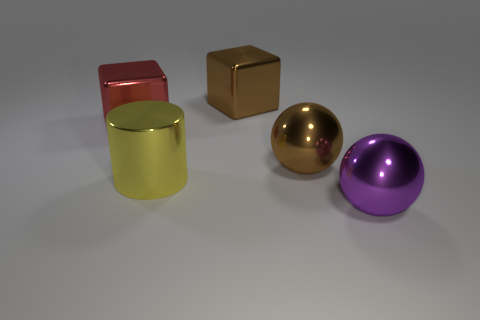What shape is the brown metal thing behind the big brown object that is in front of the metal object left of the big metallic cylinder?
Offer a terse response. Cube. What is the color of the large metal cube in front of the brown block?
Your response must be concise. Red. What number of things are either big brown shiny objects that are on the left side of the brown sphere or big blocks that are right of the red shiny object?
Offer a very short reply. 1. How many other large objects are the same shape as the purple object?
Your answer should be compact. 1. What is the color of the cylinder that is the same size as the purple metal ball?
Your answer should be very brief. Yellow. What is the color of the metal block that is in front of the shiny thing behind the metallic object that is left of the large metal cylinder?
Make the answer very short. Red. There is a metallic cylinder; is it the same size as the ball that is in front of the cylinder?
Keep it short and to the point. Yes. How many things are either big purple metal objects or objects?
Ensure brevity in your answer.  5. Are there any other big spheres made of the same material as the large brown sphere?
Your answer should be very brief. Yes. There is a shiny thing that is behind the block that is left of the big yellow thing; what is its color?
Ensure brevity in your answer.  Brown. 